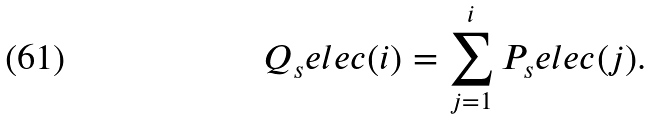Convert formula to latex. <formula><loc_0><loc_0><loc_500><loc_500>Q _ { s } e l e c ( i ) = \sum _ { j = 1 } ^ { i } P _ { s } e l e c ( j ) .</formula> 